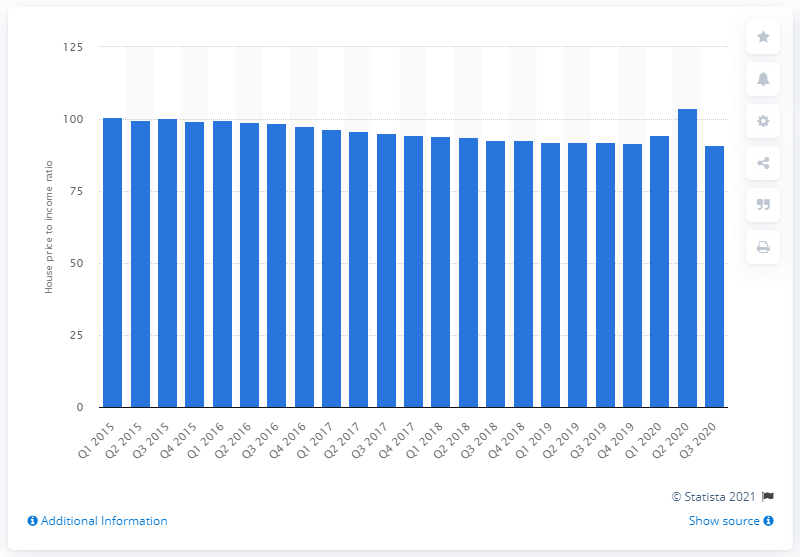Point out several critical features in this image. In the second quarter of 2020, the house price to income ratio in Italy was 103.84, indicating that the median house price in the country was 103.84 times the median household income. 